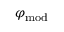<formula> <loc_0><loc_0><loc_500><loc_500>\varphi _ { m o d }</formula> 